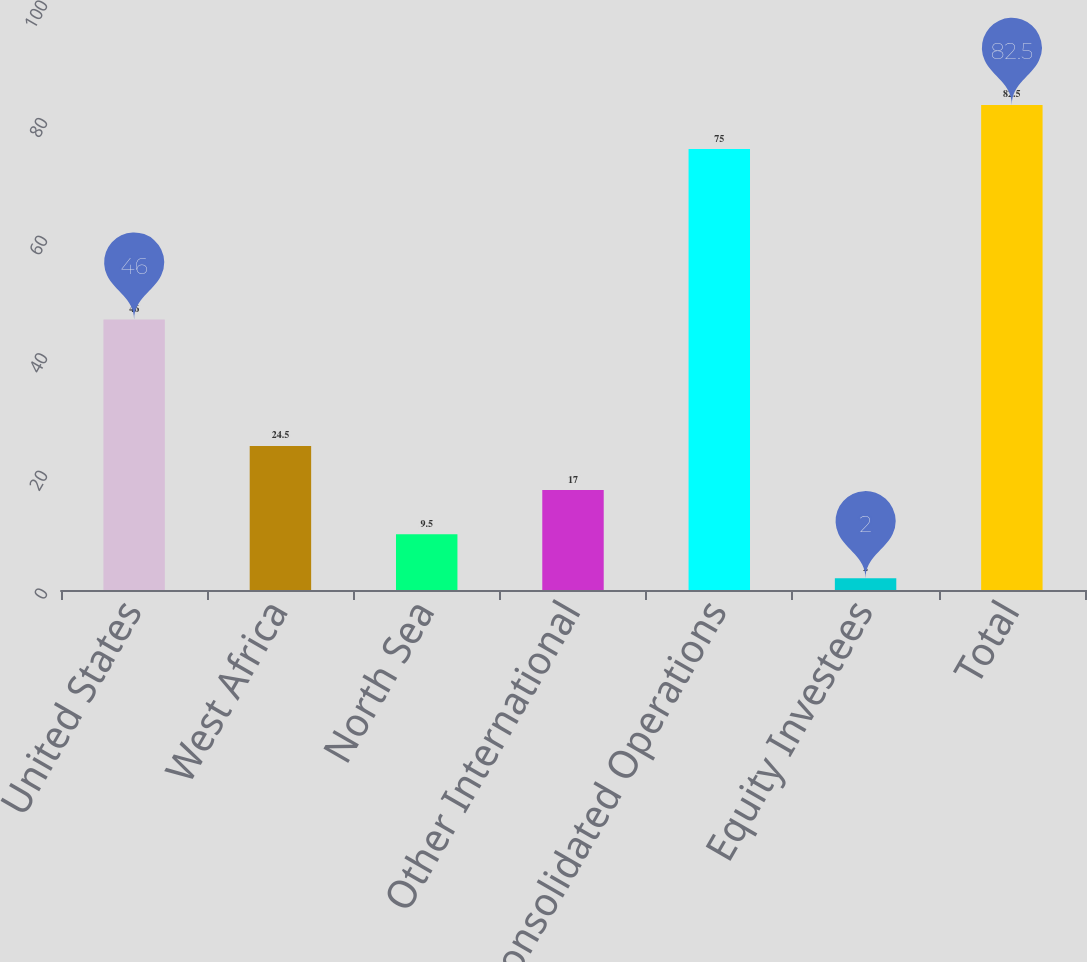Convert chart. <chart><loc_0><loc_0><loc_500><loc_500><bar_chart><fcel>United States<fcel>West Africa<fcel>North Sea<fcel>Other International<fcel>Total Consolidated Operations<fcel>Equity Investees<fcel>Total<nl><fcel>46<fcel>24.5<fcel>9.5<fcel>17<fcel>75<fcel>2<fcel>82.5<nl></chart> 